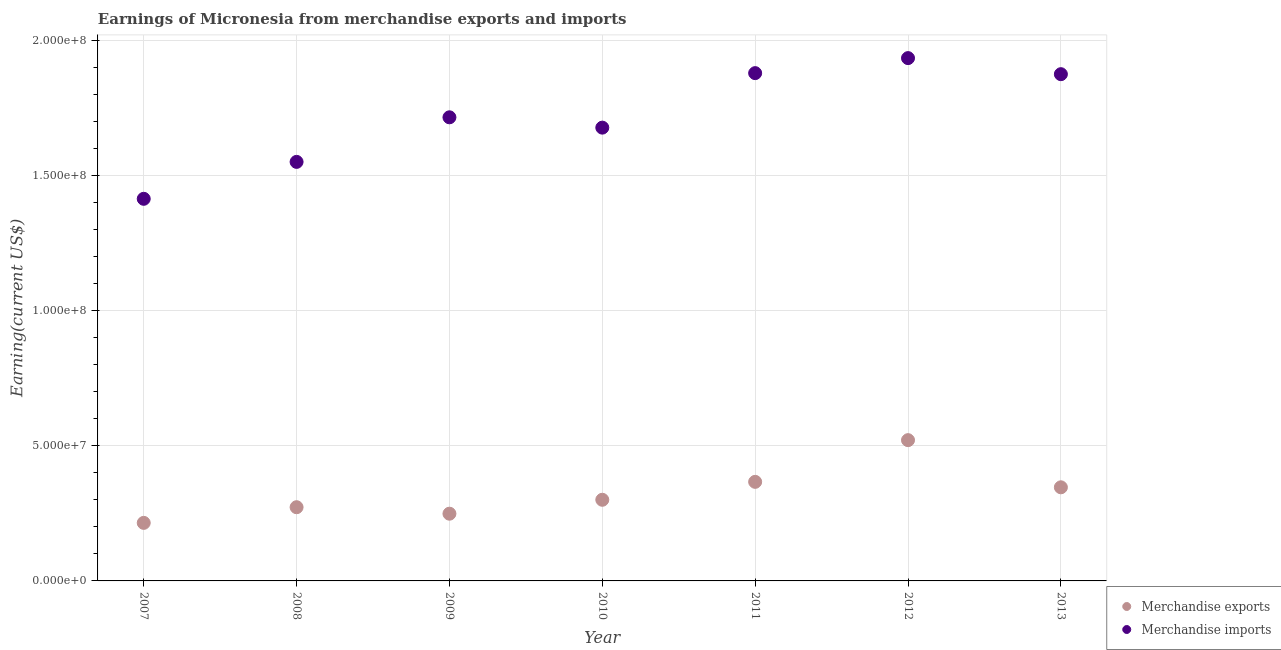How many different coloured dotlines are there?
Keep it short and to the point. 2. What is the earnings from merchandise imports in 2010?
Your answer should be compact. 1.68e+08. Across all years, what is the maximum earnings from merchandise imports?
Make the answer very short. 1.94e+08. Across all years, what is the minimum earnings from merchandise exports?
Give a very brief answer. 2.15e+07. In which year was the earnings from merchandise exports maximum?
Offer a very short reply. 2012. What is the total earnings from merchandise exports in the graph?
Provide a succinct answer. 2.27e+08. What is the difference between the earnings from merchandise exports in 2011 and that in 2013?
Give a very brief answer. 2.02e+06. What is the difference between the earnings from merchandise exports in 2007 and the earnings from merchandise imports in 2009?
Your response must be concise. -1.50e+08. What is the average earnings from merchandise imports per year?
Make the answer very short. 1.72e+08. In the year 2007, what is the difference between the earnings from merchandise imports and earnings from merchandise exports?
Offer a terse response. 1.20e+08. In how many years, is the earnings from merchandise imports greater than 60000000 US$?
Ensure brevity in your answer.  7. What is the ratio of the earnings from merchandise exports in 2008 to that in 2012?
Give a very brief answer. 0.52. Is the difference between the earnings from merchandise exports in 2010 and 2012 greater than the difference between the earnings from merchandise imports in 2010 and 2012?
Ensure brevity in your answer.  Yes. What is the difference between the highest and the second highest earnings from merchandise exports?
Provide a succinct answer. 1.54e+07. What is the difference between the highest and the lowest earnings from merchandise exports?
Your response must be concise. 3.06e+07. In how many years, is the earnings from merchandise imports greater than the average earnings from merchandise imports taken over all years?
Offer a very short reply. 3. Is the sum of the earnings from merchandise exports in 2010 and 2013 greater than the maximum earnings from merchandise imports across all years?
Your answer should be compact. No. Does the earnings from merchandise imports monotonically increase over the years?
Ensure brevity in your answer.  No. How many dotlines are there?
Provide a succinct answer. 2. How many years are there in the graph?
Your answer should be very brief. 7. What is the difference between two consecutive major ticks on the Y-axis?
Provide a succinct answer. 5.00e+07. Does the graph contain any zero values?
Give a very brief answer. No. Does the graph contain grids?
Provide a succinct answer. Yes. How are the legend labels stacked?
Give a very brief answer. Vertical. What is the title of the graph?
Offer a very short reply. Earnings of Micronesia from merchandise exports and imports. Does "Official aid received" appear as one of the legend labels in the graph?
Make the answer very short. No. What is the label or title of the Y-axis?
Your answer should be very brief. Earning(current US$). What is the Earning(current US$) of Merchandise exports in 2007?
Your response must be concise. 2.15e+07. What is the Earning(current US$) of Merchandise imports in 2007?
Your answer should be very brief. 1.42e+08. What is the Earning(current US$) in Merchandise exports in 2008?
Give a very brief answer. 2.73e+07. What is the Earning(current US$) of Merchandise imports in 2008?
Keep it short and to the point. 1.55e+08. What is the Earning(current US$) in Merchandise exports in 2009?
Offer a very short reply. 2.49e+07. What is the Earning(current US$) of Merchandise imports in 2009?
Provide a short and direct response. 1.72e+08. What is the Earning(current US$) of Merchandise exports in 2010?
Ensure brevity in your answer.  3.01e+07. What is the Earning(current US$) of Merchandise imports in 2010?
Ensure brevity in your answer.  1.68e+08. What is the Earning(current US$) of Merchandise exports in 2011?
Give a very brief answer. 3.67e+07. What is the Earning(current US$) in Merchandise imports in 2011?
Provide a succinct answer. 1.88e+08. What is the Earning(current US$) of Merchandise exports in 2012?
Keep it short and to the point. 5.21e+07. What is the Earning(current US$) in Merchandise imports in 2012?
Make the answer very short. 1.94e+08. What is the Earning(current US$) of Merchandise exports in 2013?
Provide a succinct answer. 3.47e+07. What is the Earning(current US$) of Merchandise imports in 2013?
Make the answer very short. 1.88e+08. Across all years, what is the maximum Earning(current US$) of Merchandise exports?
Provide a short and direct response. 5.21e+07. Across all years, what is the maximum Earning(current US$) of Merchandise imports?
Provide a succinct answer. 1.94e+08. Across all years, what is the minimum Earning(current US$) in Merchandise exports?
Provide a short and direct response. 2.15e+07. Across all years, what is the minimum Earning(current US$) in Merchandise imports?
Make the answer very short. 1.42e+08. What is the total Earning(current US$) of Merchandise exports in the graph?
Provide a succinct answer. 2.27e+08. What is the total Earning(current US$) in Merchandise imports in the graph?
Offer a terse response. 1.21e+09. What is the difference between the Earning(current US$) in Merchandise exports in 2007 and that in 2008?
Your answer should be very brief. -5.80e+06. What is the difference between the Earning(current US$) in Merchandise imports in 2007 and that in 2008?
Give a very brief answer. -1.37e+07. What is the difference between the Earning(current US$) of Merchandise exports in 2007 and that in 2009?
Your answer should be compact. -3.40e+06. What is the difference between the Earning(current US$) of Merchandise imports in 2007 and that in 2009?
Your answer should be very brief. -3.02e+07. What is the difference between the Earning(current US$) in Merchandise exports in 2007 and that in 2010?
Ensure brevity in your answer.  -8.55e+06. What is the difference between the Earning(current US$) of Merchandise imports in 2007 and that in 2010?
Give a very brief answer. -2.64e+07. What is the difference between the Earning(current US$) of Merchandise exports in 2007 and that in 2011?
Make the answer very short. -1.52e+07. What is the difference between the Earning(current US$) of Merchandise imports in 2007 and that in 2011?
Your answer should be very brief. -4.65e+07. What is the difference between the Earning(current US$) in Merchandise exports in 2007 and that in 2012?
Ensure brevity in your answer.  -3.06e+07. What is the difference between the Earning(current US$) of Merchandise imports in 2007 and that in 2012?
Your response must be concise. -5.21e+07. What is the difference between the Earning(current US$) in Merchandise exports in 2007 and that in 2013?
Offer a very short reply. -1.32e+07. What is the difference between the Earning(current US$) in Merchandise imports in 2007 and that in 2013?
Your response must be concise. -4.62e+07. What is the difference between the Earning(current US$) in Merchandise exports in 2008 and that in 2009?
Provide a succinct answer. 2.40e+06. What is the difference between the Earning(current US$) of Merchandise imports in 2008 and that in 2009?
Offer a very short reply. -1.65e+07. What is the difference between the Earning(current US$) in Merchandise exports in 2008 and that in 2010?
Your answer should be compact. -2.75e+06. What is the difference between the Earning(current US$) of Merchandise imports in 2008 and that in 2010?
Make the answer very short. -1.27e+07. What is the difference between the Earning(current US$) of Merchandise exports in 2008 and that in 2011?
Keep it short and to the point. -9.39e+06. What is the difference between the Earning(current US$) of Merchandise imports in 2008 and that in 2011?
Your answer should be compact. -3.29e+07. What is the difference between the Earning(current US$) of Merchandise exports in 2008 and that in 2012?
Offer a very short reply. -2.48e+07. What is the difference between the Earning(current US$) of Merchandise imports in 2008 and that in 2012?
Ensure brevity in your answer.  -3.84e+07. What is the difference between the Earning(current US$) of Merchandise exports in 2008 and that in 2013?
Make the answer very short. -7.38e+06. What is the difference between the Earning(current US$) of Merchandise imports in 2008 and that in 2013?
Keep it short and to the point. -3.25e+07. What is the difference between the Earning(current US$) in Merchandise exports in 2009 and that in 2010?
Your response must be concise. -5.15e+06. What is the difference between the Earning(current US$) in Merchandise imports in 2009 and that in 2010?
Provide a short and direct response. 3.83e+06. What is the difference between the Earning(current US$) in Merchandise exports in 2009 and that in 2011?
Make the answer very short. -1.18e+07. What is the difference between the Earning(current US$) in Merchandise imports in 2009 and that in 2011?
Make the answer very short. -1.64e+07. What is the difference between the Earning(current US$) in Merchandise exports in 2009 and that in 2012?
Ensure brevity in your answer.  -2.72e+07. What is the difference between the Earning(current US$) in Merchandise imports in 2009 and that in 2012?
Give a very brief answer. -2.19e+07. What is the difference between the Earning(current US$) of Merchandise exports in 2009 and that in 2013?
Your response must be concise. -9.78e+06. What is the difference between the Earning(current US$) of Merchandise imports in 2009 and that in 2013?
Keep it short and to the point. -1.60e+07. What is the difference between the Earning(current US$) in Merchandise exports in 2010 and that in 2011?
Ensure brevity in your answer.  -6.64e+06. What is the difference between the Earning(current US$) of Merchandise imports in 2010 and that in 2011?
Keep it short and to the point. -2.02e+07. What is the difference between the Earning(current US$) of Merchandise exports in 2010 and that in 2012?
Your answer should be very brief. -2.21e+07. What is the difference between the Earning(current US$) of Merchandise imports in 2010 and that in 2012?
Provide a short and direct response. -2.58e+07. What is the difference between the Earning(current US$) in Merchandise exports in 2010 and that in 2013?
Give a very brief answer. -4.62e+06. What is the difference between the Earning(current US$) of Merchandise imports in 2010 and that in 2013?
Offer a terse response. -1.98e+07. What is the difference between the Earning(current US$) of Merchandise exports in 2011 and that in 2012?
Ensure brevity in your answer.  -1.54e+07. What is the difference between the Earning(current US$) in Merchandise imports in 2011 and that in 2012?
Your answer should be compact. -5.56e+06. What is the difference between the Earning(current US$) of Merchandise exports in 2011 and that in 2013?
Provide a succinct answer. 2.02e+06. What is the difference between the Earning(current US$) in Merchandise imports in 2011 and that in 2013?
Make the answer very short. 3.89e+05. What is the difference between the Earning(current US$) of Merchandise exports in 2012 and that in 2013?
Give a very brief answer. 1.75e+07. What is the difference between the Earning(current US$) of Merchandise imports in 2012 and that in 2013?
Your answer should be compact. 5.95e+06. What is the difference between the Earning(current US$) in Merchandise exports in 2007 and the Earning(current US$) in Merchandise imports in 2008?
Give a very brief answer. -1.34e+08. What is the difference between the Earning(current US$) of Merchandise exports in 2007 and the Earning(current US$) of Merchandise imports in 2009?
Offer a terse response. -1.50e+08. What is the difference between the Earning(current US$) in Merchandise exports in 2007 and the Earning(current US$) in Merchandise imports in 2010?
Give a very brief answer. -1.46e+08. What is the difference between the Earning(current US$) of Merchandise exports in 2007 and the Earning(current US$) of Merchandise imports in 2011?
Keep it short and to the point. -1.67e+08. What is the difference between the Earning(current US$) of Merchandise exports in 2007 and the Earning(current US$) of Merchandise imports in 2012?
Provide a short and direct response. -1.72e+08. What is the difference between the Earning(current US$) of Merchandise exports in 2007 and the Earning(current US$) of Merchandise imports in 2013?
Make the answer very short. -1.66e+08. What is the difference between the Earning(current US$) in Merchandise exports in 2008 and the Earning(current US$) in Merchandise imports in 2009?
Make the answer very short. -1.44e+08. What is the difference between the Earning(current US$) in Merchandise exports in 2008 and the Earning(current US$) in Merchandise imports in 2010?
Your response must be concise. -1.41e+08. What is the difference between the Earning(current US$) in Merchandise exports in 2008 and the Earning(current US$) in Merchandise imports in 2011?
Offer a terse response. -1.61e+08. What is the difference between the Earning(current US$) of Merchandise exports in 2008 and the Earning(current US$) of Merchandise imports in 2012?
Provide a short and direct response. -1.66e+08. What is the difference between the Earning(current US$) of Merchandise exports in 2008 and the Earning(current US$) of Merchandise imports in 2013?
Your response must be concise. -1.60e+08. What is the difference between the Earning(current US$) of Merchandise exports in 2009 and the Earning(current US$) of Merchandise imports in 2010?
Keep it short and to the point. -1.43e+08. What is the difference between the Earning(current US$) of Merchandise exports in 2009 and the Earning(current US$) of Merchandise imports in 2011?
Keep it short and to the point. -1.63e+08. What is the difference between the Earning(current US$) of Merchandise exports in 2009 and the Earning(current US$) of Merchandise imports in 2012?
Your answer should be very brief. -1.69e+08. What is the difference between the Earning(current US$) in Merchandise exports in 2009 and the Earning(current US$) in Merchandise imports in 2013?
Your answer should be compact. -1.63e+08. What is the difference between the Earning(current US$) of Merchandise exports in 2010 and the Earning(current US$) of Merchandise imports in 2011?
Make the answer very short. -1.58e+08. What is the difference between the Earning(current US$) of Merchandise exports in 2010 and the Earning(current US$) of Merchandise imports in 2012?
Keep it short and to the point. -1.64e+08. What is the difference between the Earning(current US$) in Merchandise exports in 2010 and the Earning(current US$) in Merchandise imports in 2013?
Offer a terse response. -1.58e+08. What is the difference between the Earning(current US$) in Merchandise exports in 2011 and the Earning(current US$) in Merchandise imports in 2012?
Give a very brief answer. -1.57e+08. What is the difference between the Earning(current US$) in Merchandise exports in 2011 and the Earning(current US$) in Merchandise imports in 2013?
Keep it short and to the point. -1.51e+08. What is the difference between the Earning(current US$) of Merchandise exports in 2012 and the Earning(current US$) of Merchandise imports in 2013?
Provide a short and direct response. -1.36e+08. What is the average Earning(current US$) in Merchandise exports per year?
Your answer should be compact. 3.25e+07. What is the average Earning(current US$) in Merchandise imports per year?
Offer a very short reply. 1.72e+08. In the year 2007, what is the difference between the Earning(current US$) in Merchandise exports and Earning(current US$) in Merchandise imports?
Keep it short and to the point. -1.20e+08. In the year 2008, what is the difference between the Earning(current US$) in Merchandise exports and Earning(current US$) in Merchandise imports?
Provide a succinct answer. -1.28e+08. In the year 2009, what is the difference between the Earning(current US$) of Merchandise exports and Earning(current US$) of Merchandise imports?
Make the answer very short. -1.47e+08. In the year 2010, what is the difference between the Earning(current US$) of Merchandise exports and Earning(current US$) of Merchandise imports?
Provide a succinct answer. -1.38e+08. In the year 2011, what is the difference between the Earning(current US$) in Merchandise exports and Earning(current US$) in Merchandise imports?
Provide a succinct answer. -1.51e+08. In the year 2012, what is the difference between the Earning(current US$) of Merchandise exports and Earning(current US$) of Merchandise imports?
Ensure brevity in your answer.  -1.42e+08. In the year 2013, what is the difference between the Earning(current US$) in Merchandise exports and Earning(current US$) in Merchandise imports?
Make the answer very short. -1.53e+08. What is the ratio of the Earning(current US$) of Merchandise exports in 2007 to that in 2008?
Provide a short and direct response. 0.79. What is the ratio of the Earning(current US$) of Merchandise imports in 2007 to that in 2008?
Keep it short and to the point. 0.91. What is the ratio of the Earning(current US$) in Merchandise exports in 2007 to that in 2009?
Provide a short and direct response. 0.86. What is the ratio of the Earning(current US$) of Merchandise imports in 2007 to that in 2009?
Provide a succinct answer. 0.82. What is the ratio of the Earning(current US$) in Merchandise exports in 2007 to that in 2010?
Provide a succinct answer. 0.72. What is the ratio of the Earning(current US$) in Merchandise imports in 2007 to that in 2010?
Provide a short and direct response. 0.84. What is the ratio of the Earning(current US$) of Merchandise exports in 2007 to that in 2011?
Offer a terse response. 0.59. What is the ratio of the Earning(current US$) of Merchandise imports in 2007 to that in 2011?
Provide a succinct answer. 0.75. What is the ratio of the Earning(current US$) of Merchandise exports in 2007 to that in 2012?
Ensure brevity in your answer.  0.41. What is the ratio of the Earning(current US$) in Merchandise imports in 2007 to that in 2012?
Offer a very short reply. 0.73. What is the ratio of the Earning(current US$) of Merchandise exports in 2007 to that in 2013?
Keep it short and to the point. 0.62. What is the ratio of the Earning(current US$) in Merchandise imports in 2007 to that in 2013?
Your response must be concise. 0.75. What is the ratio of the Earning(current US$) of Merchandise exports in 2008 to that in 2009?
Make the answer very short. 1.1. What is the ratio of the Earning(current US$) in Merchandise imports in 2008 to that in 2009?
Offer a terse response. 0.9. What is the ratio of the Earning(current US$) in Merchandise exports in 2008 to that in 2010?
Offer a terse response. 0.91. What is the ratio of the Earning(current US$) in Merchandise imports in 2008 to that in 2010?
Your response must be concise. 0.92. What is the ratio of the Earning(current US$) of Merchandise exports in 2008 to that in 2011?
Your answer should be very brief. 0.74. What is the ratio of the Earning(current US$) in Merchandise imports in 2008 to that in 2011?
Provide a succinct answer. 0.83. What is the ratio of the Earning(current US$) in Merchandise exports in 2008 to that in 2012?
Ensure brevity in your answer.  0.52. What is the ratio of the Earning(current US$) of Merchandise imports in 2008 to that in 2012?
Ensure brevity in your answer.  0.8. What is the ratio of the Earning(current US$) in Merchandise exports in 2008 to that in 2013?
Provide a short and direct response. 0.79. What is the ratio of the Earning(current US$) in Merchandise imports in 2008 to that in 2013?
Your answer should be very brief. 0.83. What is the ratio of the Earning(current US$) in Merchandise exports in 2009 to that in 2010?
Make the answer very short. 0.83. What is the ratio of the Earning(current US$) of Merchandise imports in 2009 to that in 2010?
Keep it short and to the point. 1.02. What is the ratio of the Earning(current US$) in Merchandise exports in 2009 to that in 2011?
Give a very brief answer. 0.68. What is the ratio of the Earning(current US$) of Merchandise imports in 2009 to that in 2011?
Make the answer very short. 0.91. What is the ratio of the Earning(current US$) in Merchandise exports in 2009 to that in 2012?
Your response must be concise. 0.48. What is the ratio of the Earning(current US$) of Merchandise imports in 2009 to that in 2012?
Your response must be concise. 0.89. What is the ratio of the Earning(current US$) of Merchandise exports in 2009 to that in 2013?
Offer a very short reply. 0.72. What is the ratio of the Earning(current US$) of Merchandise imports in 2009 to that in 2013?
Make the answer very short. 0.91. What is the ratio of the Earning(current US$) of Merchandise exports in 2010 to that in 2011?
Ensure brevity in your answer.  0.82. What is the ratio of the Earning(current US$) of Merchandise imports in 2010 to that in 2011?
Give a very brief answer. 0.89. What is the ratio of the Earning(current US$) of Merchandise exports in 2010 to that in 2012?
Your answer should be compact. 0.58. What is the ratio of the Earning(current US$) in Merchandise imports in 2010 to that in 2012?
Your answer should be very brief. 0.87. What is the ratio of the Earning(current US$) of Merchandise exports in 2010 to that in 2013?
Your response must be concise. 0.87. What is the ratio of the Earning(current US$) in Merchandise imports in 2010 to that in 2013?
Your response must be concise. 0.89. What is the ratio of the Earning(current US$) in Merchandise exports in 2011 to that in 2012?
Your answer should be compact. 0.7. What is the ratio of the Earning(current US$) of Merchandise imports in 2011 to that in 2012?
Your response must be concise. 0.97. What is the ratio of the Earning(current US$) of Merchandise exports in 2011 to that in 2013?
Provide a short and direct response. 1.06. What is the ratio of the Earning(current US$) of Merchandise exports in 2012 to that in 2013?
Your answer should be compact. 1.5. What is the ratio of the Earning(current US$) of Merchandise imports in 2012 to that in 2013?
Offer a very short reply. 1.03. What is the difference between the highest and the second highest Earning(current US$) of Merchandise exports?
Offer a terse response. 1.54e+07. What is the difference between the highest and the second highest Earning(current US$) of Merchandise imports?
Your answer should be compact. 5.56e+06. What is the difference between the highest and the lowest Earning(current US$) of Merchandise exports?
Your response must be concise. 3.06e+07. What is the difference between the highest and the lowest Earning(current US$) of Merchandise imports?
Make the answer very short. 5.21e+07. 